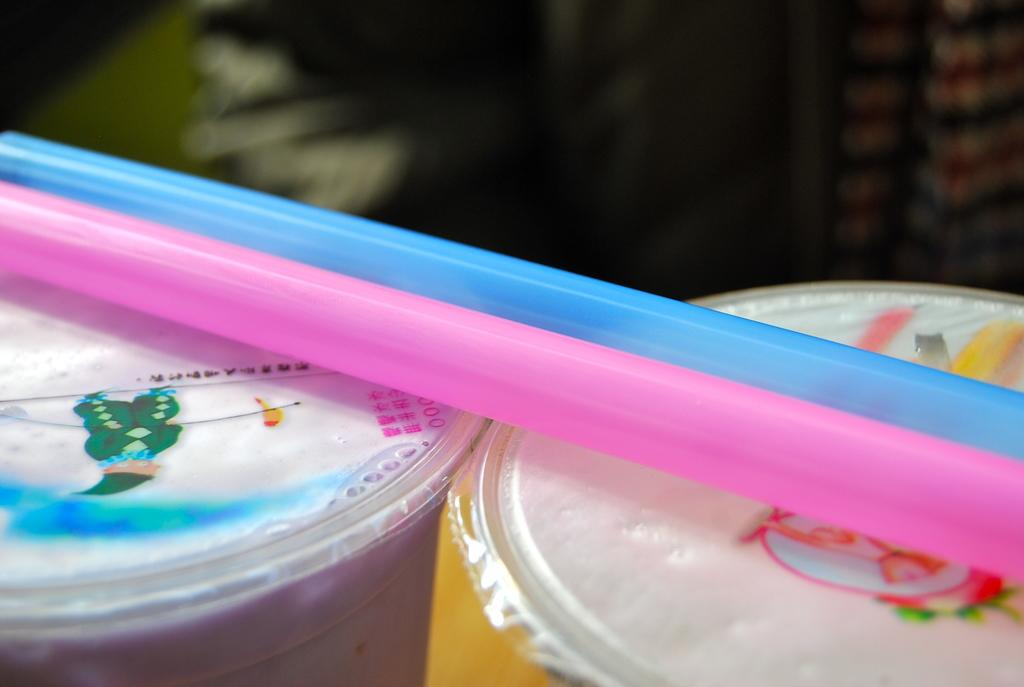How many plastic boxes are visible in the image? There are two plastic boxes in the image. What is placed on the plastic boxes? There are two straws on the plastic boxes. Can you describe the straws in the image? One straw is pink in color, and the other straw is blue in color. What type of flesh can be seen on the plastic boxes in the image? There is no flesh present on the plastic boxes in the image. What activity is taking place in the image? The image does not depict any specific activity; it simply shows two plastic boxes with straws on them. 